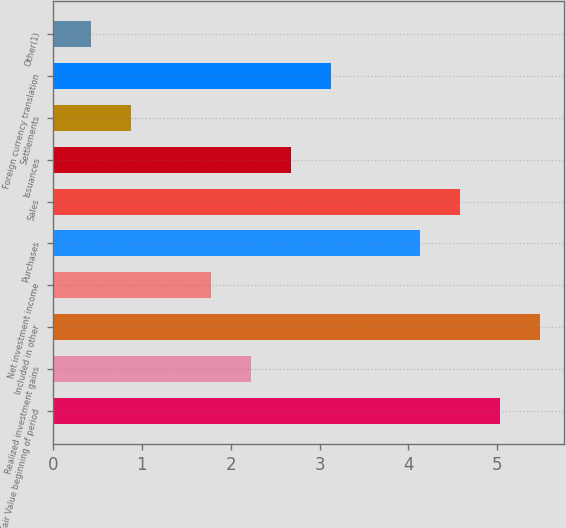Convert chart to OTSL. <chart><loc_0><loc_0><loc_500><loc_500><bar_chart><fcel>Fair Value beginning of period<fcel>Realized investment gains<fcel>Included in other<fcel>Net investment income<fcel>Purchases<fcel>Sales<fcel>Issuances<fcel>Settlements<fcel>Foreign currency translation<fcel>Other(1)<nl><fcel>5.03<fcel>2.23<fcel>5.48<fcel>1.78<fcel>4.13<fcel>4.58<fcel>2.68<fcel>0.88<fcel>3.13<fcel>0.43<nl></chart> 